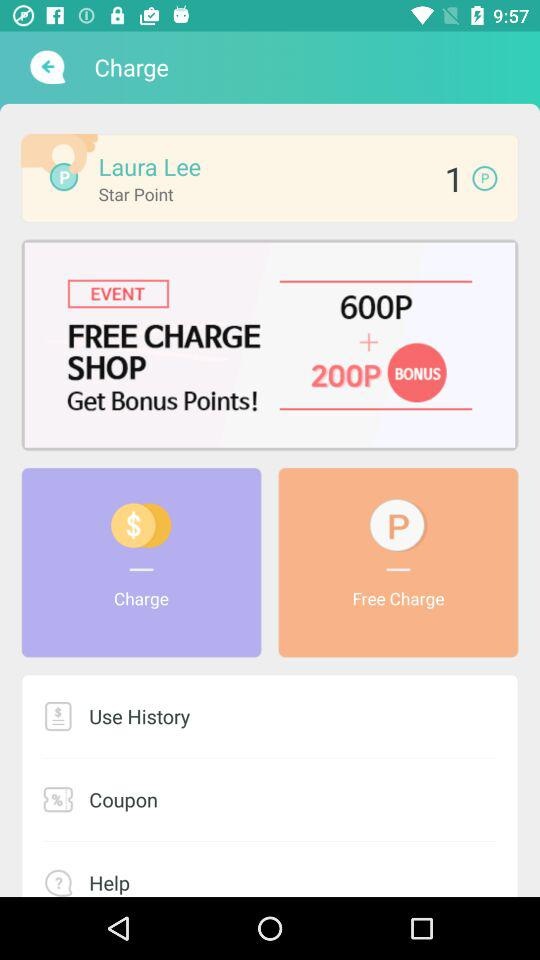How many points does Laura Lee have?
Answer the question using a single word or phrase. 1 